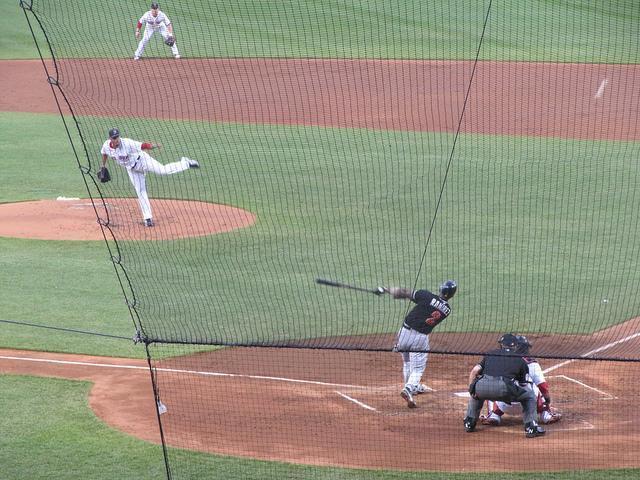What is the position of the player in the middle of the field?
Choose the right answer from the provided options to respond to the question.
Options: First baseman, pitcher, outfielder, shortstop. Pitcher. 